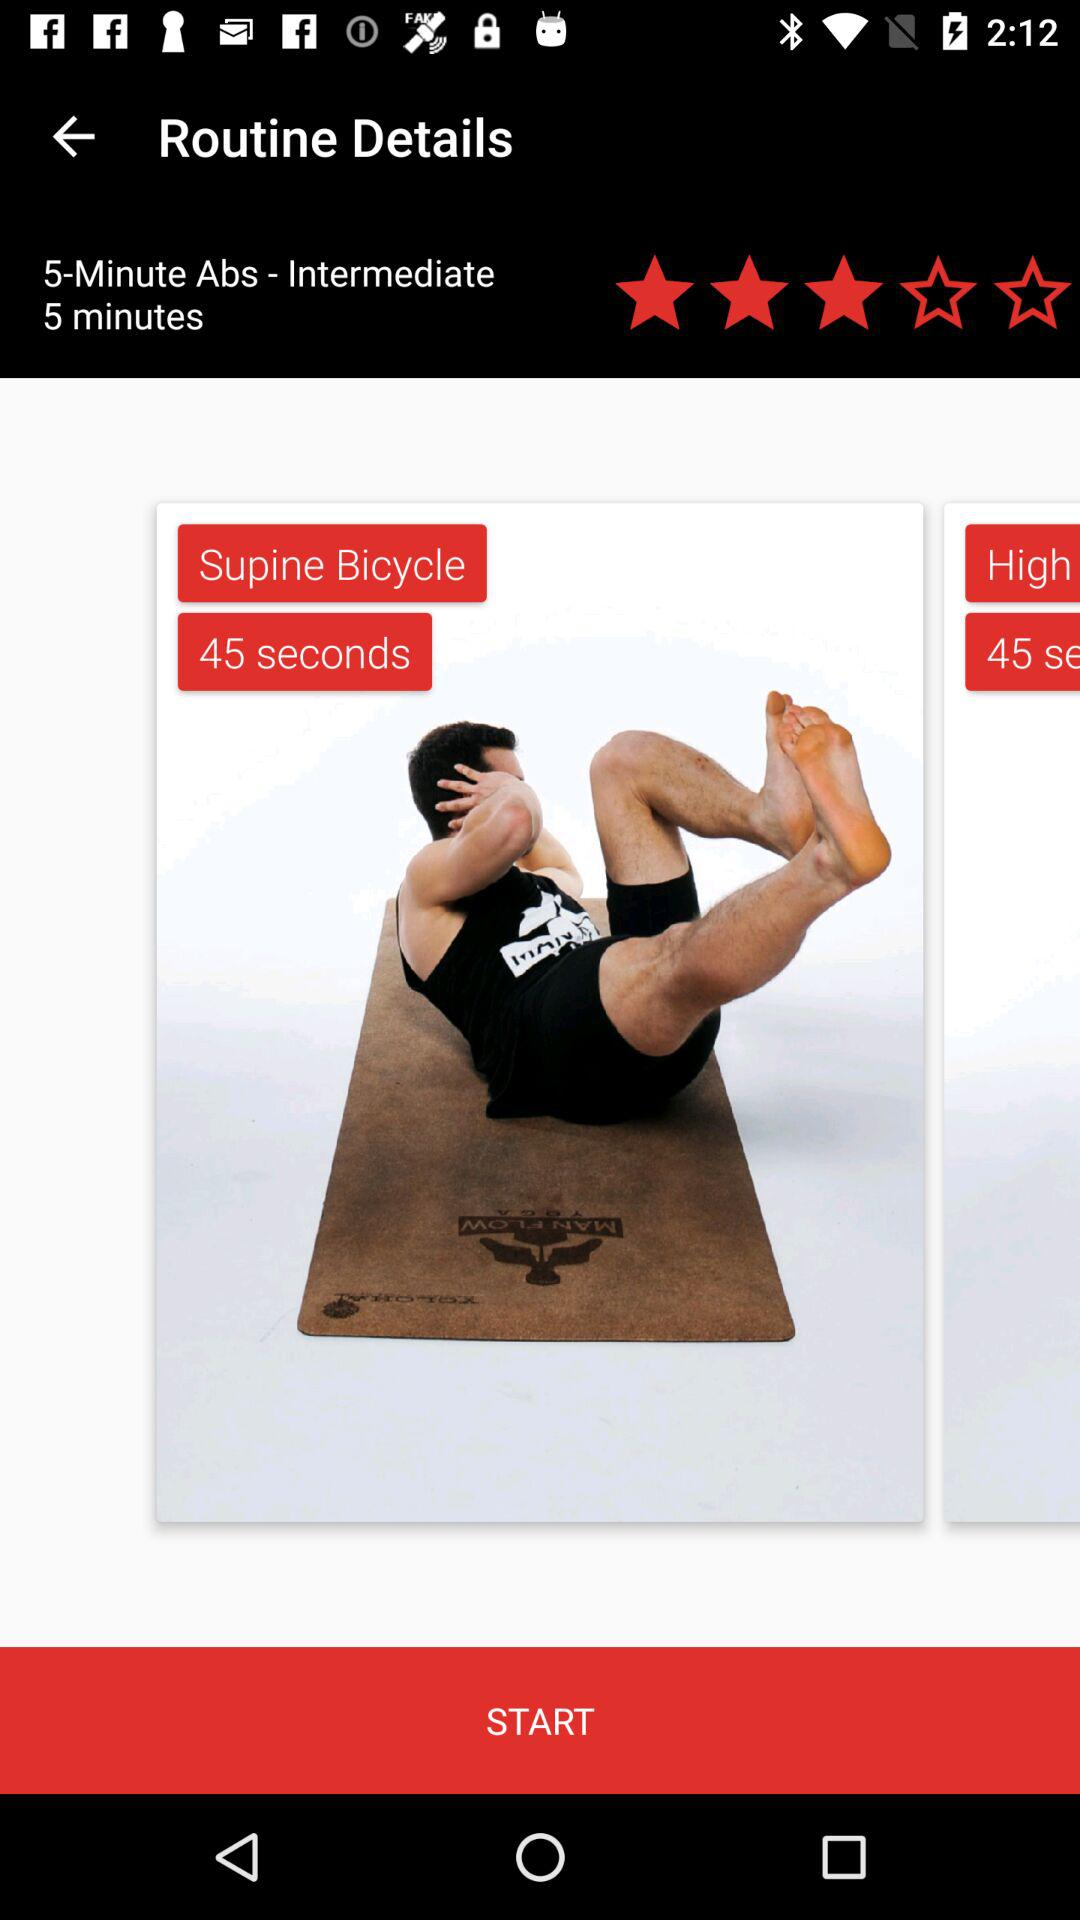Which exercise is rated three stars? The exercise is "Supine Bicycle". 